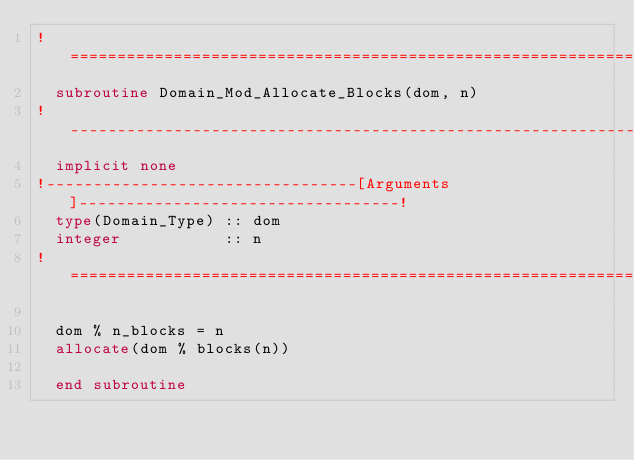<code> <loc_0><loc_0><loc_500><loc_500><_FORTRAN_>!==============================================================================!
  subroutine Domain_Mod_Allocate_Blocks(dom, n)
!------------------------------------------------------------------------------!
  implicit none
!---------------------------------[Arguments]----------------------------------!
  type(Domain_Type) :: dom
  integer           :: n
!==============================================================================!

  dom % n_blocks = n
  allocate(dom % blocks(n))

  end subroutine
</code> 